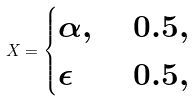<formula> <loc_0><loc_0><loc_500><loc_500>X = \begin{cases} \alpha , & \ 0 . 5 , \\ \epsilon & \ 0 . 5 , \end{cases}</formula> 